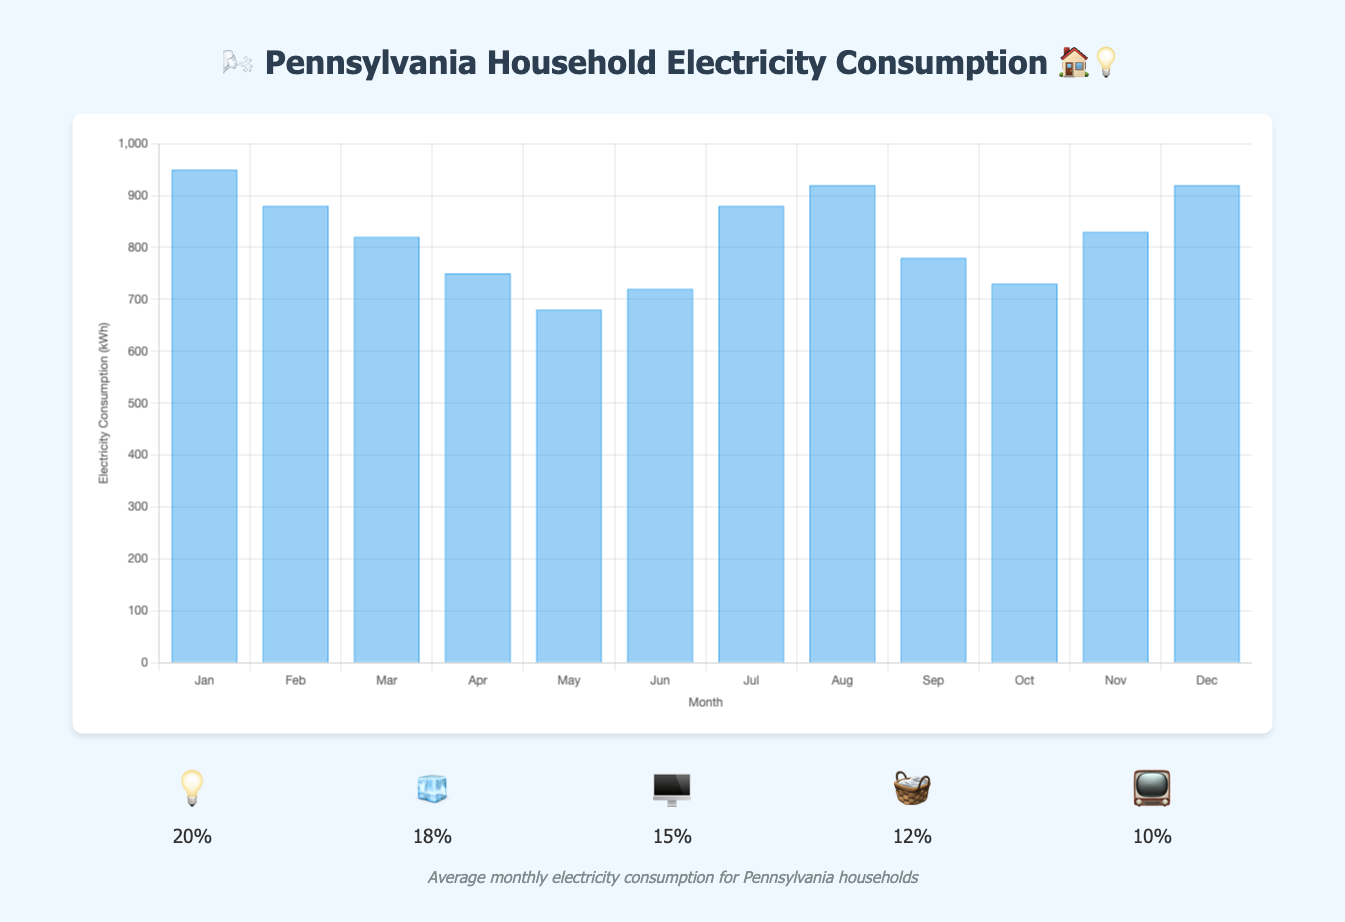Which month has the highest electricity consumption? The highest bar on the chart represents the highest electricity consumption. November and December both have a peak value of 920 kWh.
Answer: December How much more electricity is consumed in January compared to May? The bar for January shows 950 kWh of consumption, and the bar for May shows 680 kWh. The difference is 950 kWh - 680 kWh = 270 kWh.
Answer: 270 kWh What's the average monthly electricity consumption? Add up all the monthly consumption values and then divide by 12 (the number of months). (950 + 880 + 820 + 750 + 680 + 720 + 880 + 920 + 780 + 730 + 830 + 920) / 12 = 8190 / 12 = 682.5 kWh.
Answer: 682.5 kWh Which month(s) have the lowest electricity consumption? The bar for May shows the lowest electricity consumption at 680 kWh.
Answer: May How does the electricity consumption in July compare to August? The bar for July shows 880 kWh and the bar for August shows 920 kWh. August has higher consumption by 40 kWh.
Answer: August List three winter months and their corresponding electricity consumption values. Jan, Feb, and Dec are considered winter months. Jan has 950 kWh, Feb has 880 kWh, and Dec has 920 kWh.
Answer: Jan: 950 kWh, Feb: 880 kWh, Dec: 920 kWh What appliance has the highest percentage of electricity consumption? The list of top consumers shows that the light bulb (💡) has the highest percentage at 20%.
Answer: Light bulb (20%) What is the percentage difference between the electricity consumption of lights and the TV? Lights (💡) consume 20% while TV (📺) consumes 10%. The difference is 20% - 10% = 10%.
Answer: 10% During the summer months of June, July, and August, how much electricity is consumed in total? Add the consumption for June (720 kWh), July (880 kWh), and August (920 kWh). The total is 720 + 880 + 920 = 2520 kWh.
Answer: 2520 kWh Is there a significant increase in electricity consumption between March and April? The bar for March shows 820 kWh, and for April it is 750 kWh. The consumption decreases by 70 kWh (820 - 750 = 70 kWh).
Answer: No 